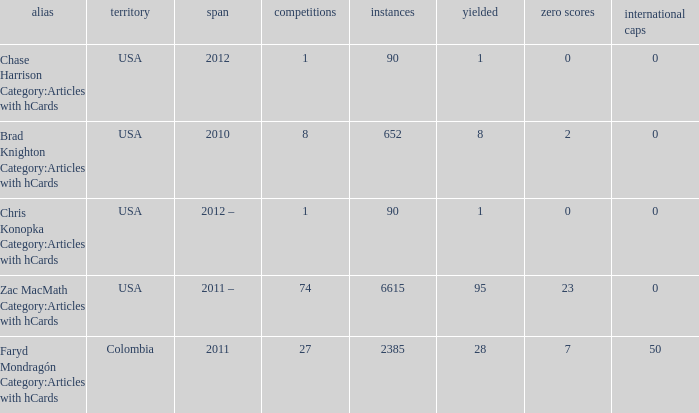What is the lowest overall amount of shutouts? 0.0. 